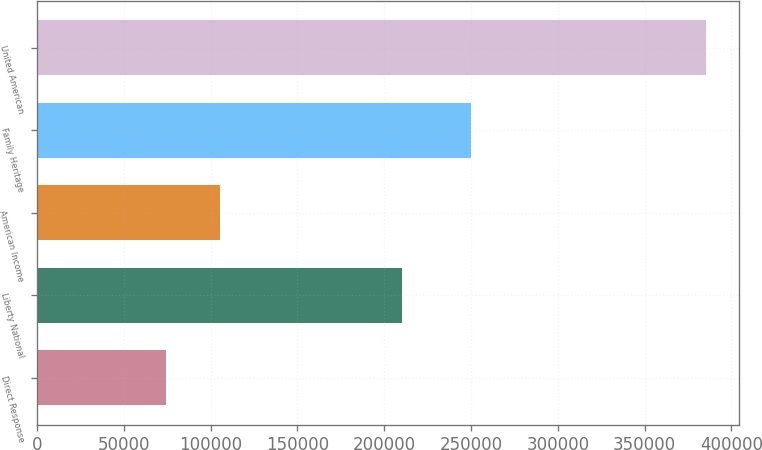Convert chart to OTSL. <chart><loc_0><loc_0><loc_500><loc_500><bar_chart><fcel>Direct Response<fcel>Liberty National<fcel>American Income<fcel>Family Heritage<fcel>United American<nl><fcel>74261<fcel>210260<fcel>105366<fcel>249857<fcel>385309<nl></chart> 